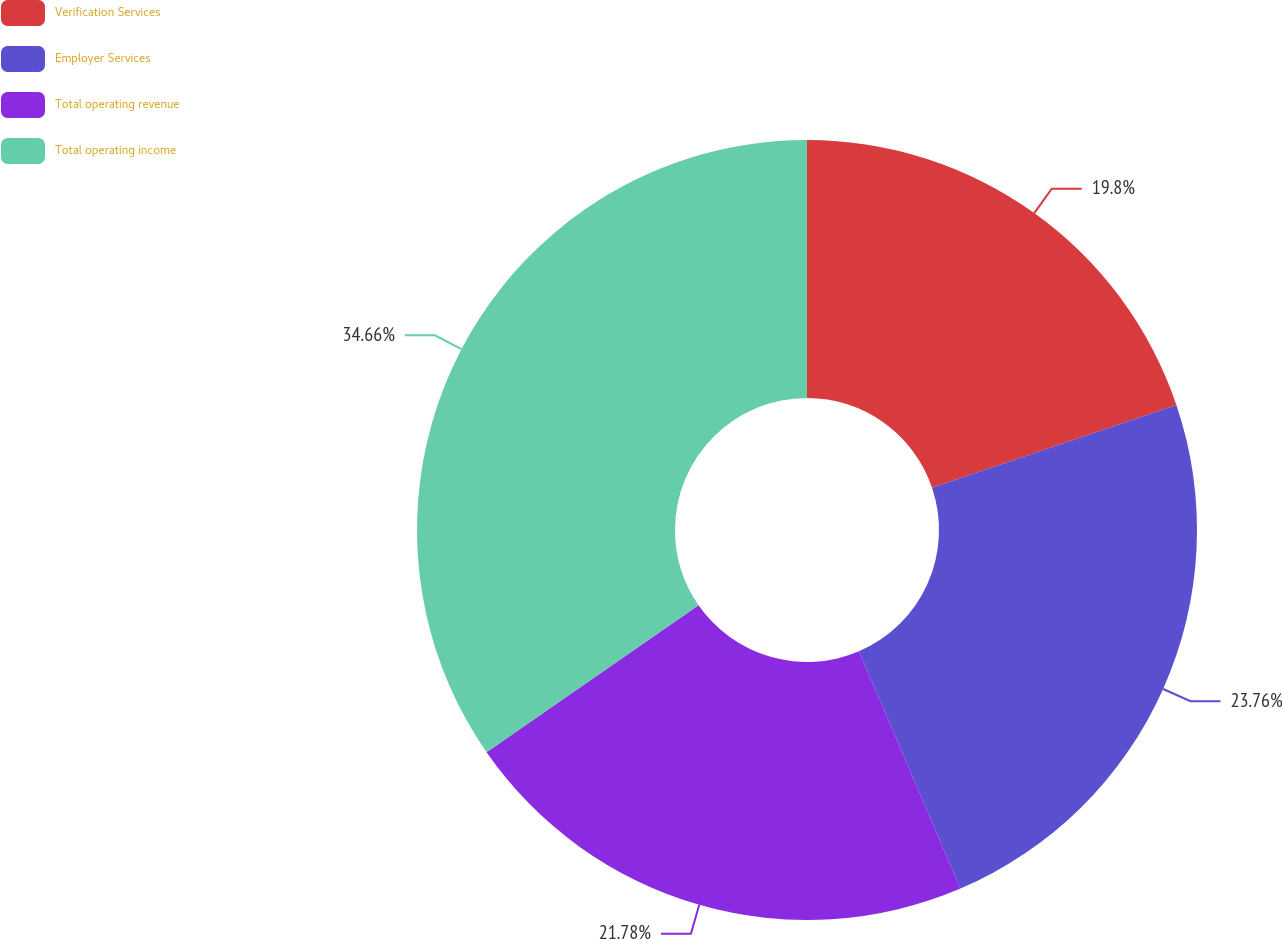<chart> <loc_0><loc_0><loc_500><loc_500><pie_chart><fcel>Verification Services<fcel>Employer Services<fcel>Total operating revenue<fcel>Total operating income<nl><fcel>19.8%<fcel>23.76%<fcel>21.78%<fcel>34.65%<nl></chart> 